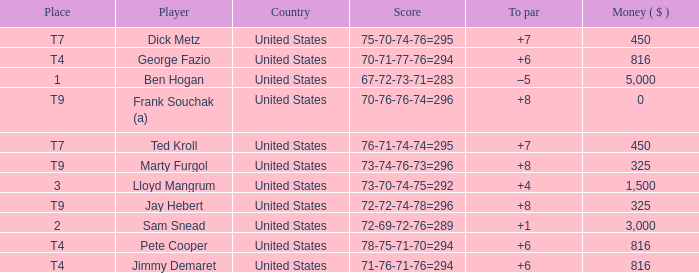What was Marty Furgol's place when he was paid less than $3,000? T9. 